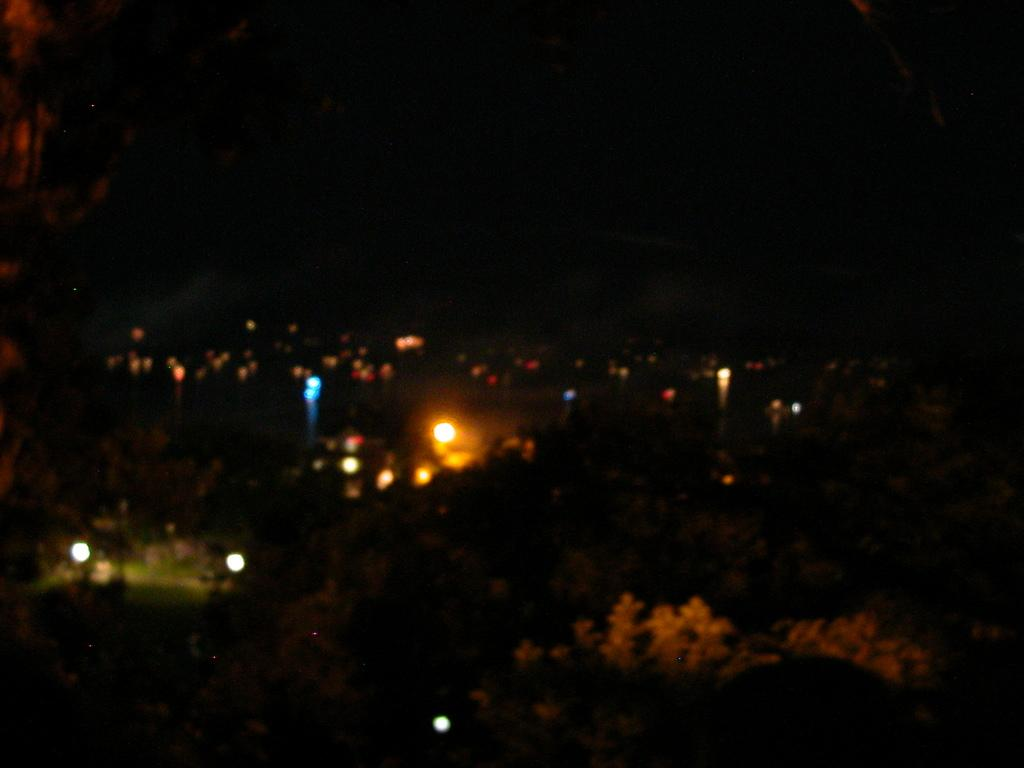What can be seen in the image that provides illumination? There are lights in the image. What type of natural elements are present in the image? There are trees in the image. What type of tent can be seen in the image? There is no tent present in the image. What word is used to say good-bye to someone in the image? There is no dialogue or interaction with people in the image, so it is not possible to determine if someone is saying good-bye. 